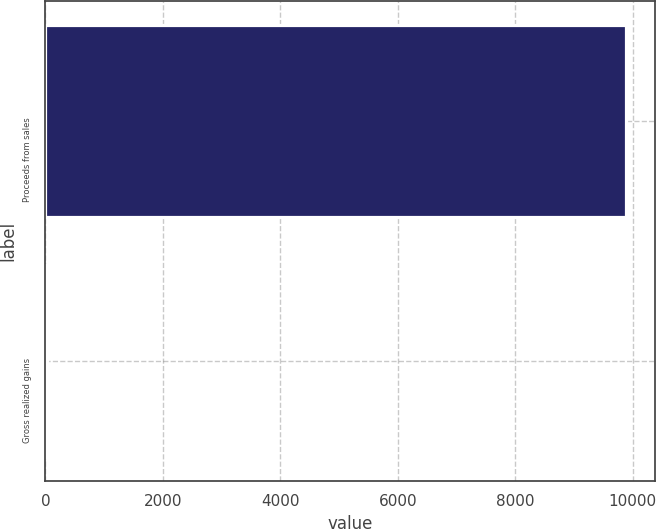Convert chart to OTSL. <chart><loc_0><loc_0><loc_500><loc_500><bar_chart><fcel>Proceeds from sales<fcel>Gross realized gains<nl><fcel>9881<fcel>36<nl></chart> 